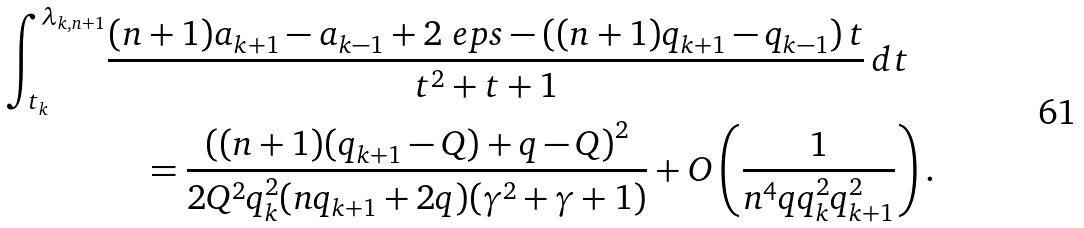<formula> <loc_0><loc_0><loc_500><loc_500>\int _ { t _ { k } } ^ { \lambda _ { k , n + 1 } } & \frac { ( n + 1 ) a _ { k + 1 } - a _ { k - 1 } + 2 \ e p s - \left ( ( n + 1 ) q _ { k + 1 } - q _ { k - 1 } \right ) t } { t ^ { 2 } + t + 1 } \, d t \\ & \quad = \frac { \left ( ( n + 1 ) ( q _ { k + 1 } - Q ) + q - Q \right ) ^ { 2 } } { 2 Q ^ { 2 } q _ { k } ^ { 2 } ( n q _ { k + 1 } + 2 q ) ( \gamma ^ { 2 } + \gamma + 1 ) } + O \left ( \frac { 1 } { n ^ { 4 } q q _ { k } ^ { 2 } q _ { k + 1 } ^ { 2 } } \right ) .</formula> 